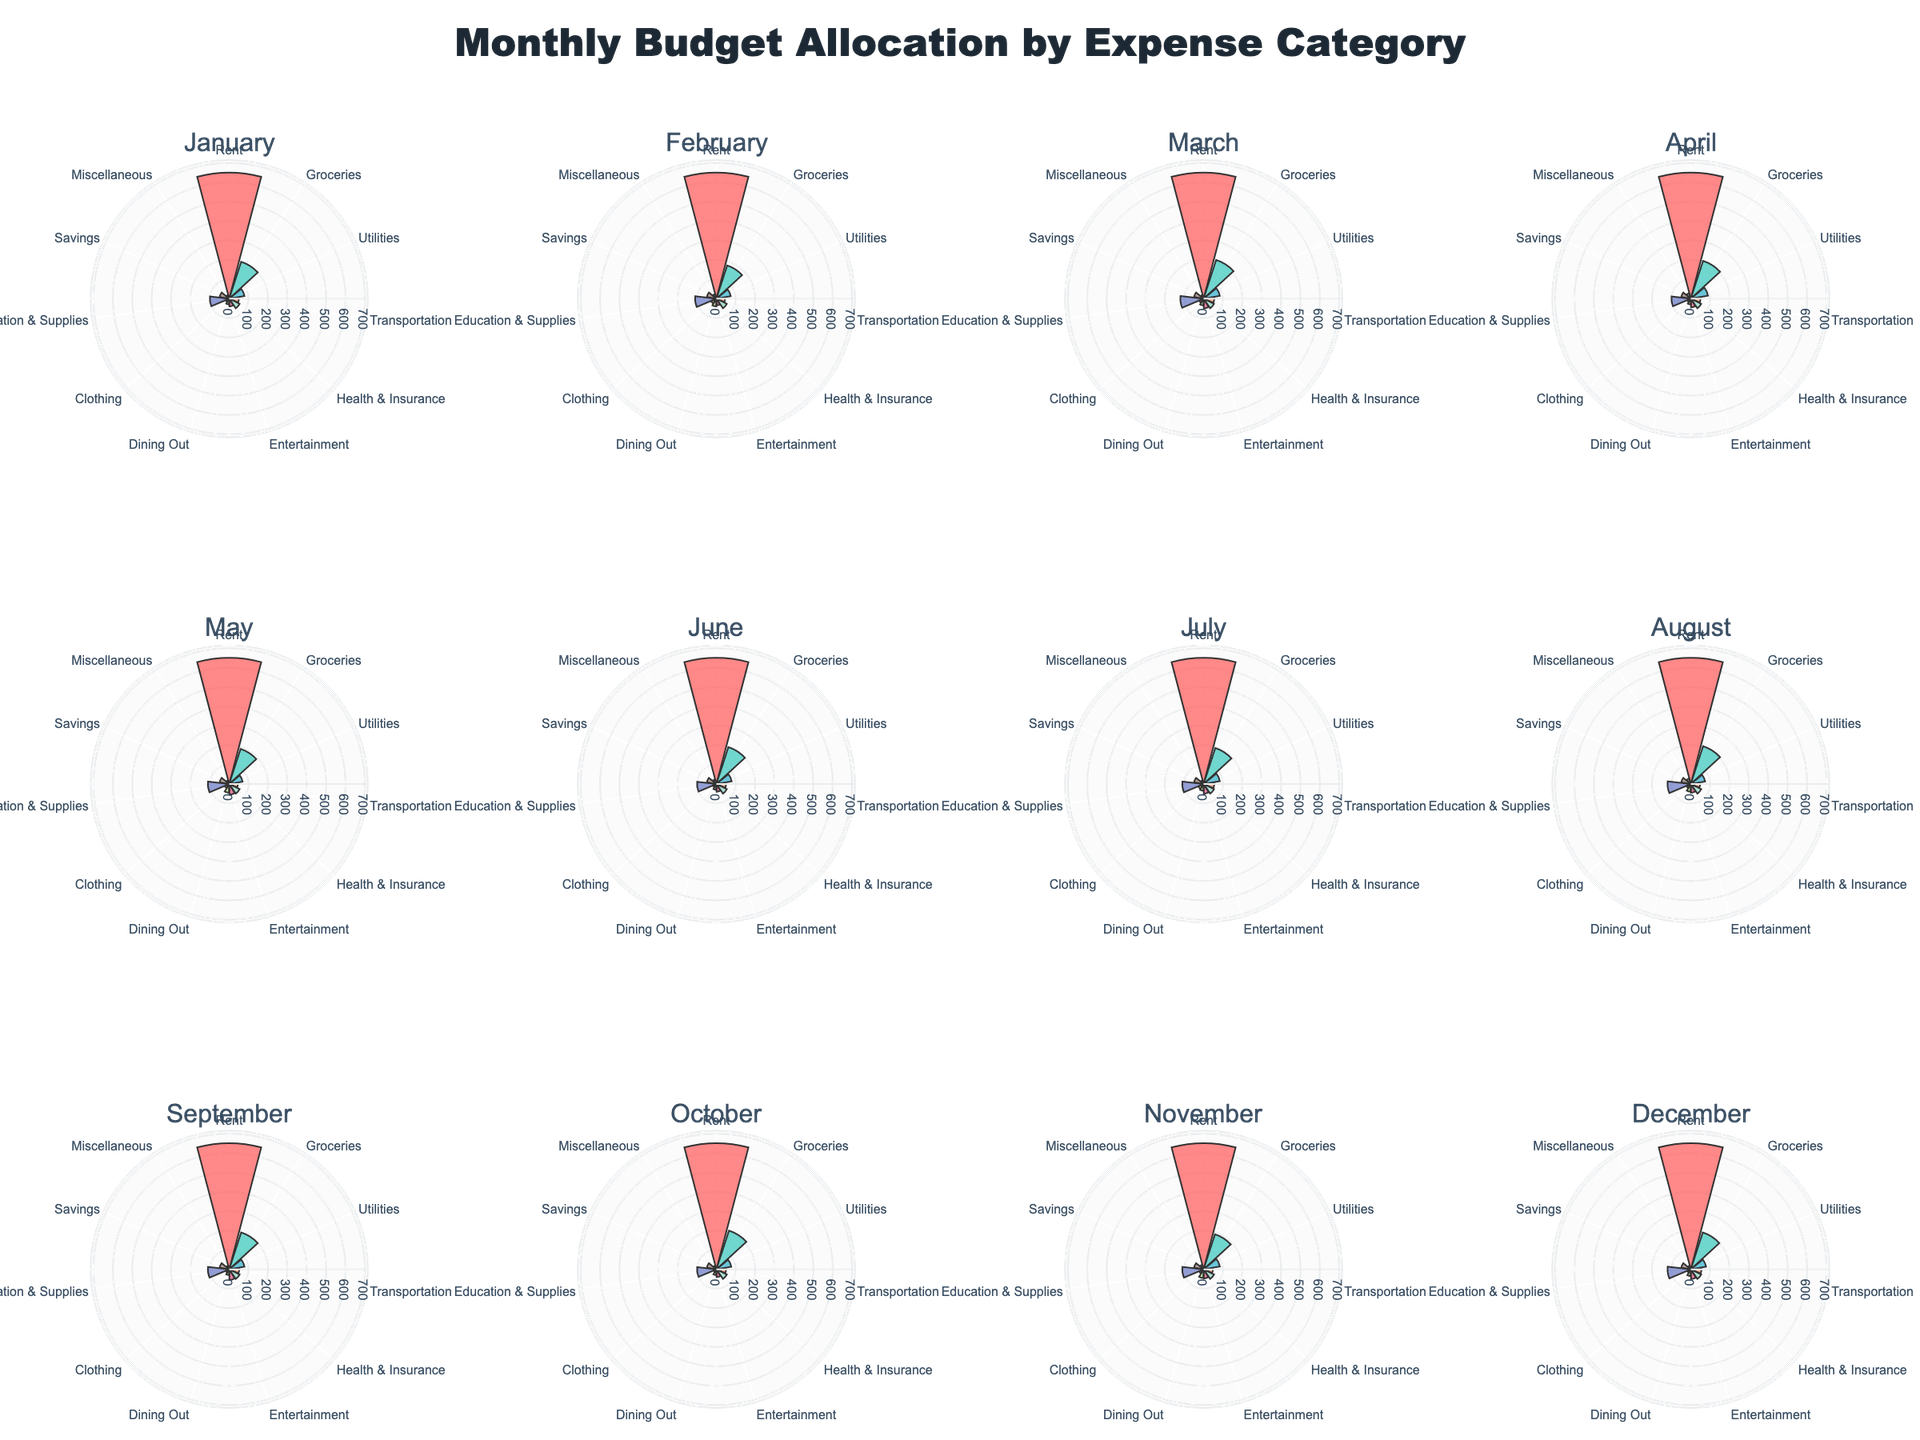Which month has the highest spending on Entertainment? By examining the subplots, locate the point on the Entertainment axis with the longest bar length in the respective month's rose chart. The chart for May shows the longest bar for Entertainment.
Answer: May How does the budget for Utilities in June compare to July? Compare the length of the bar on the Utilities axis for June and July. The length of the bar for Utilities appears longer in July than in June.
Answer: July What is the total budget allocation for Rent over the year? The Rent category remains constant every month at $650. Sum the values: $650 * 12 = $7800.
Answer: $7800 What is the average monthly allocation for Groceries? Sum the Groceries values for each month and divide by 12. The sum of Groceries for each month is 200+180+210+205+190+200+195+205+200+210+190+200 = 2385, so the average is 2385/12 ≈ 198.75.
Answer: 198.75 Is there any category where the budget stays the same throughout the year other than Rent? Identify any consistent length bars across all subplots within a single category. The Health & Insurance category maintains a constant budget of $60 each month.
Answer: Health & Insurance Which month has the lowest spending in Housing (Rent)? Look at the length of the Rent bars in all subplots; they remain constant at $650 for all months. Therefore, no month has the lowest spending as they all have the same value.
Answer: None How does dining out in March compare to December? Compare the Dining Out bars for March and December. The bar for Dining Out in March ($35) is longer than in December ($35) making them equal.
Answer: Equal Which category saw the highest increase from August to September? Examine the difference in bar lengths for each category between August and September. Education & Supplies shows an increase from 120 to 110.
Answer: Education & Supplies What is the cumulative spending on Miscellaneous for the first quarter (January, February, March)? Sum the Miscellaneous allocations for January, February, and March: 20+25+20 = 65.
Answer: 65 